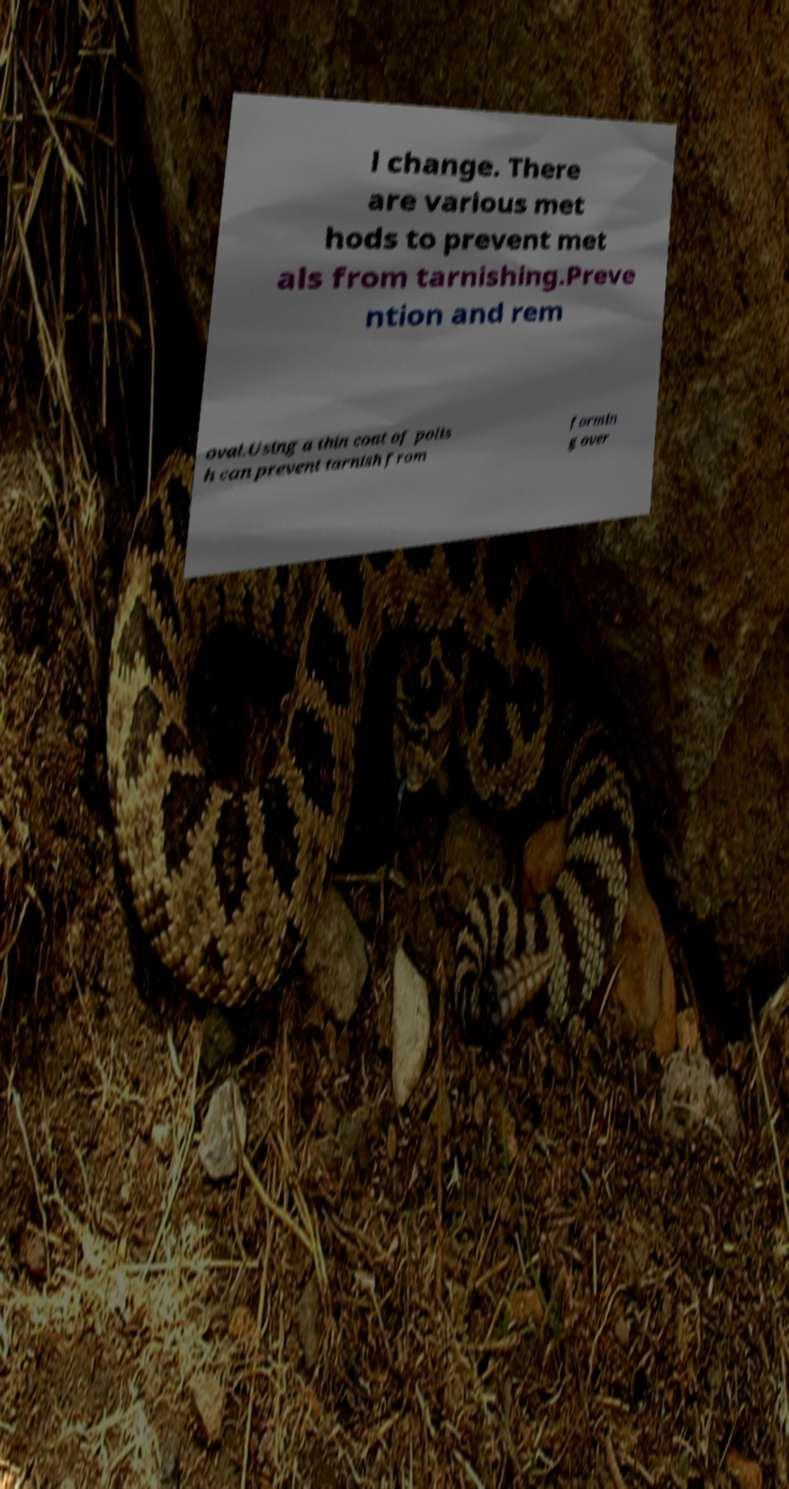Could you extract and type out the text from this image? l change. There are various met hods to prevent met als from tarnishing.Preve ntion and rem oval.Using a thin coat of polis h can prevent tarnish from formin g over 